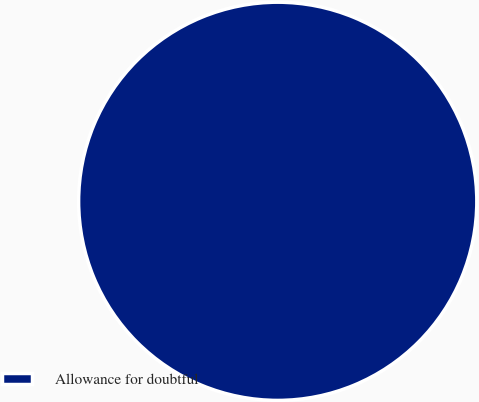<chart> <loc_0><loc_0><loc_500><loc_500><pie_chart><fcel>Allowance for doubtful<nl><fcel>100.0%<nl></chart> 